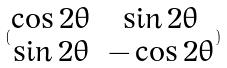Convert formula to latex. <formula><loc_0><loc_0><loc_500><loc_500>( \begin{matrix} \cos 2 \theta & \sin 2 \theta \\ \sin 2 \theta & - \cos 2 \theta \end{matrix} )</formula> 